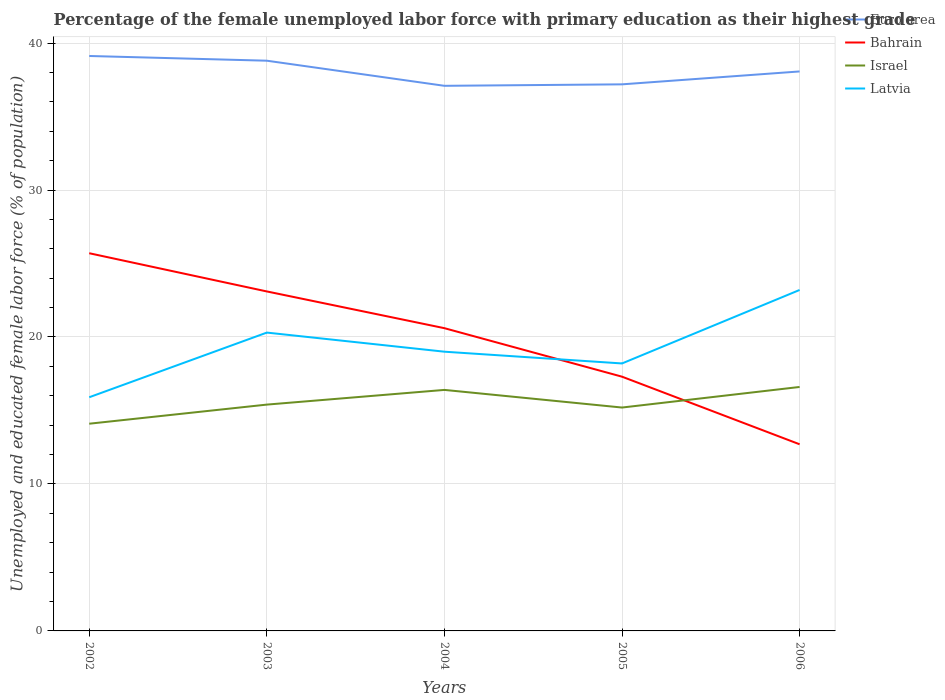Across all years, what is the maximum percentage of the unemployed female labor force with primary education in Israel?
Give a very brief answer. 14.1. In which year was the percentage of the unemployed female labor force with primary education in Euro area maximum?
Keep it short and to the point. 2004. What is the total percentage of the unemployed female labor force with primary education in Latvia in the graph?
Your response must be concise. -4.2. What is the difference between the highest and the second highest percentage of the unemployed female labor force with primary education in Latvia?
Your response must be concise. 7.3. What is the difference between the highest and the lowest percentage of the unemployed female labor force with primary education in Euro area?
Ensure brevity in your answer.  3. Is the percentage of the unemployed female labor force with primary education in Bahrain strictly greater than the percentage of the unemployed female labor force with primary education in Israel over the years?
Ensure brevity in your answer.  No. How many lines are there?
Provide a succinct answer. 4. Does the graph contain grids?
Provide a succinct answer. Yes. Where does the legend appear in the graph?
Your response must be concise. Top right. What is the title of the graph?
Keep it short and to the point. Percentage of the female unemployed labor force with primary education as their highest grade. Does "Bulgaria" appear as one of the legend labels in the graph?
Keep it short and to the point. No. What is the label or title of the Y-axis?
Offer a terse response. Unemployed and educated female labor force (% of population). What is the Unemployed and educated female labor force (% of population) of Euro area in 2002?
Your answer should be compact. 39.12. What is the Unemployed and educated female labor force (% of population) of Bahrain in 2002?
Offer a terse response. 25.7. What is the Unemployed and educated female labor force (% of population) of Israel in 2002?
Your answer should be compact. 14.1. What is the Unemployed and educated female labor force (% of population) of Latvia in 2002?
Your answer should be compact. 15.9. What is the Unemployed and educated female labor force (% of population) of Euro area in 2003?
Keep it short and to the point. 38.8. What is the Unemployed and educated female labor force (% of population) in Bahrain in 2003?
Your answer should be compact. 23.1. What is the Unemployed and educated female labor force (% of population) in Israel in 2003?
Ensure brevity in your answer.  15.4. What is the Unemployed and educated female labor force (% of population) in Latvia in 2003?
Give a very brief answer. 20.3. What is the Unemployed and educated female labor force (% of population) of Euro area in 2004?
Provide a short and direct response. 37.09. What is the Unemployed and educated female labor force (% of population) in Bahrain in 2004?
Provide a short and direct response. 20.6. What is the Unemployed and educated female labor force (% of population) of Israel in 2004?
Offer a terse response. 16.4. What is the Unemployed and educated female labor force (% of population) of Euro area in 2005?
Provide a short and direct response. 37.19. What is the Unemployed and educated female labor force (% of population) in Bahrain in 2005?
Offer a terse response. 17.3. What is the Unemployed and educated female labor force (% of population) in Israel in 2005?
Provide a succinct answer. 15.2. What is the Unemployed and educated female labor force (% of population) in Latvia in 2005?
Offer a terse response. 18.2. What is the Unemployed and educated female labor force (% of population) of Euro area in 2006?
Provide a succinct answer. 38.07. What is the Unemployed and educated female labor force (% of population) in Bahrain in 2006?
Offer a very short reply. 12.7. What is the Unemployed and educated female labor force (% of population) in Israel in 2006?
Your answer should be compact. 16.6. What is the Unemployed and educated female labor force (% of population) in Latvia in 2006?
Your response must be concise. 23.2. Across all years, what is the maximum Unemployed and educated female labor force (% of population) in Euro area?
Ensure brevity in your answer.  39.12. Across all years, what is the maximum Unemployed and educated female labor force (% of population) in Bahrain?
Your answer should be compact. 25.7. Across all years, what is the maximum Unemployed and educated female labor force (% of population) of Israel?
Offer a very short reply. 16.6. Across all years, what is the maximum Unemployed and educated female labor force (% of population) of Latvia?
Provide a succinct answer. 23.2. Across all years, what is the minimum Unemployed and educated female labor force (% of population) in Euro area?
Make the answer very short. 37.09. Across all years, what is the minimum Unemployed and educated female labor force (% of population) in Bahrain?
Your answer should be compact. 12.7. Across all years, what is the minimum Unemployed and educated female labor force (% of population) of Israel?
Provide a succinct answer. 14.1. Across all years, what is the minimum Unemployed and educated female labor force (% of population) of Latvia?
Make the answer very short. 15.9. What is the total Unemployed and educated female labor force (% of population) of Euro area in the graph?
Keep it short and to the point. 190.27. What is the total Unemployed and educated female labor force (% of population) in Bahrain in the graph?
Offer a very short reply. 99.4. What is the total Unemployed and educated female labor force (% of population) in Israel in the graph?
Give a very brief answer. 77.7. What is the total Unemployed and educated female labor force (% of population) in Latvia in the graph?
Your response must be concise. 96.6. What is the difference between the Unemployed and educated female labor force (% of population) in Euro area in 2002 and that in 2003?
Make the answer very short. 0.32. What is the difference between the Unemployed and educated female labor force (% of population) in Bahrain in 2002 and that in 2003?
Offer a very short reply. 2.6. What is the difference between the Unemployed and educated female labor force (% of population) in Israel in 2002 and that in 2003?
Offer a very short reply. -1.3. What is the difference between the Unemployed and educated female labor force (% of population) of Latvia in 2002 and that in 2003?
Offer a very short reply. -4.4. What is the difference between the Unemployed and educated female labor force (% of population) of Euro area in 2002 and that in 2004?
Your answer should be compact. 2.03. What is the difference between the Unemployed and educated female labor force (% of population) of Euro area in 2002 and that in 2005?
Provide a succinct answer. 1.93. What is the difference between the Unemployed and educated female labor force (% of population) in Israel in 2002 and that in 2005?
Provide a short and direct response. -1.1. What is the difference between the Unemployed and educated female labor force (% of population) in Latvia in 2002 and that in 2005?
Keep it short and to the point. -2.3. What is the difference between the Unemployed and educated female labor force (% of population) in Euro area in 2002 and that in 2006?
Your answer should be compact. 1.05. What is the difference between the Unemployed and educated female labor force (% of population) of Bahrain in 2002 and that in 2006?
Offer a terse response. 13. What is the difference between the Unemployed and educated female labor force (% of population) in Israel in 2002 and that in 2006?
Your answer should be compact. -2.5. What is the difference between the Unemployed and educated female labor force (% of population) in Euro area in 2003 and that in 2004?
Keep it short and to the point. 1.71. What is the difference between the Unemployed and educated female labor force (% of population) of Bahrain in 2003 and that in 2004?
Ensure brevity in your answer.  2.5. What is the difference between the Unemployed and educated female labor force (% of population) in Israel in 2003 and that in 2004?
Your response must be concise. -1. What is the difference between the Unemployed and educated female labor force (% of population) of Euro area in 2003 and that in 2005?
Provide a short and direct response. 1.61. What is the difference between the Unemployed and educated female labor force (% of population) of Euro area in 2003 and that in 2006?
Give a very brief answer. 0.73. What is the difference between the Unemployed and educated female labor force (% of population) in Euro area in 2004 and that in 2005?
Provide a succinct answer. -0.1. What is the difference between the Unemployed and educated female labor force (% of population) of Israel in 2004 and that in 2005?
Ensure brevity in your answer.  1.2. What is the difference between the Unemployed and educated female labor force (% of population) of Latvia in 2004 and that in 2005?
Offer a terse response. 0.8. What is the difference between the Unemployed and educated female labor force (% of population) in Euro area in 2004 and that in 2006?
Offer a terse response. -0.98. What is the difference between the Unemployed and educated female labor force (% of population) in Euro area in 2005 and that in 2006?
Your response must be concise. -0.88. What is the difference between the Unemployed and educated female labor force (% of population) of Bahrain in 2005 and that in 2006?
Ensure brevity in your answer.  4.6. What is the difference between the Unemployed and educated female labor force (% of population) in Euro area in 2002 and the Unemployed and educated female labor force (% of population) in Bahrain in 2003?
Make the answer very short. 16.02. What is the difference between the Unemployed and educated female labor force (% of population) of Euro area in 2002 and the Unemployed and educated female labor force (% of population) of Israel in 2003?
Keep it short and to the point. 23.72. What is the difference between the Unemployed and educated female labor force (% of population) in Euro area in 2002 and the Unemployed and educated female labor force (% of population) in Latvia in 2003?
Give a very brief answer. 18.82. What is the difference between the Unemployed and educated female labor force (% of population) in Bahrain in 2002 and the Unemployed and educated female labor force (% of population) in Latvia in 2003?
Make the answer very short. 5.4. What is the difference between the Unemployed and educated female labor force (% of population) of Euro area in 2002 and the Unemployed and educated female labor force (% of population) of Bahrain in 2004?
Ensure brevity in your answer.  18.52. What is the difference between the Unemployed and educated female labor force (% of population) of Euro area in 2002 and the Unemployed and educated female labor force (% of population) of Israel in 2004?
Keep it short and to the point. 22.72. What is the difference between the Unemployed and educated female labor force (% of population) in Euro area in 2002 and the Unemployed and educated female labor force (% of population) in Latvia in 2004?
Your answer should be compact. 20.12. What is the difference between the Unemployed and educated female labor force (% of population) of Bahrain in 2002 and the Unemployed and educated female labor force (% of population) of Israel in 2004?
Keep it short and to the point. 9.3. What is the difference between the Unemployed and educated female labor force (% of population) of Israel in 2002 and the Unemployed and educated female labor force (% of population) of Latvia in 2004?
Provide a succinct answer. -4.9. What is the difference between the Unemployed and educated female labor force (% of population) of Euro area in 2002 and the Unemployed and educated female labor force (% of population) of Bahrain in 2005?
Ensure brevity in your answer.  21.82. What is the difference between the Unemployed and educated female labor force (% of population) in Euro area in 2002 and the Unemployed and educated female labor force (% of population) in Israel in 2005?
Provide a short and direct response. 23.92. What is the difference between the Unemployed and educated female labor force (% of population) of Euro area in 2002 and the Unemployed and educated female labor force (% of population) of Latvia in 2005?
Provide a succinct answer. 20.92. What is the difference between the Unemployed and educated female labor force (% of population) of Bahrain in 2002 and the Unemployed and educated female labor force (% of population) of Latvia in 2005?
Offer a very short reply. 7.5. What is the difference between the Unemployed and educated female labor force (% of population) of Euro area in 2002 and the Unemployed and educated female labor force (% of population) of Bahrain in 2006?
Make the answer very short. 26.42. What is the difference between the Unemployed and educated female labor force (% of population) in Euro area in 2002 and the Unemployed and educated female labor force (% of population) in Israel in 2006?
Ensure brevity in your answer.  22.52. What is the difference between the Unemployed and educated female labor force (% of population) of Euro area in 2002 and the Unemployed and educated female labor force (% of population) of Latvia in 2006?
Provide a succinct answer. 15.92. What is the difference between the Unemployed and educated female labor force (% of population) in Bahrain in 2002 and the Unemployed and educated female labor force (% of population) in Israel in 2006?
Make the answer very short. 9.1. What is the difference between the Unemployed and educated female labor force (% of population) in Bahrain in 2002 and the Unemployed and educated female labor force (% of population) in Latvia in 2006?
Your response must be concise. 2.5. What is the difference between the Unemployed and educated female labor force (% of population) of Israel in 2002 and the Unemployed and educated female labor force (% of population) of Latvia in 2006?
Provide a short and direct response. -9.1. What is the difference between the Unemployed and educated female labor force (% of population) of Euro area in 2003 and the Unemployed and educated female labor force (% of population) of Bahrain in 2004?
Offer a very short reply. 18.2. What is the difference between the Unemployed and educated female labor force (% of population) in Euro area in 2003 and the Unemployed and educated female labor force (% of population) in Israel in 2004?
Make the answer very short. 22.4. What is the difference between the Unemployed and educated female labor force (% of population) of Euro area in 2003 and the Unemployed and educated female labor force (% of population) of Latvia in 2004?
Ensure brevity in your answer.  19.8. What is the difference between the Unemployed and educated female labor force (% of population) in Bahrain in 2003 and the Unemployed and educated female labor force (% of population) in Israel in 2004?
Your answer should be very brief. 6.7. What is the difference between the Unemployed and educated female labor force (% of population) in Bahrain in 2003 and the Unemployed and educated female labor force (% of population) in Latvia in 2004?
Ensure brevity in your answer.  4.1. What is the difference between the Unemployed and educated female labor force (% of population) of Israel in 2003 and the Unemployed and educated female labor force (% of population) of Latvia in 2004?
Provide a succinct answer. -3.6. What is the difference between the Unemployed and educated female labor force (% of population) in Euro area in 2003 and the Unemployed and educated female labor force (% of population) in Bahrain in 2005?
Ensure brevity in your answer.  21.5. What is the difference between the Unemployed and educated female labor force (% of population) in Euro area in 2003 and the Unemployed and educated female labor force (% of population) in Israel in 2005?
Give a very brief answer. 23.6. What is the difference between the Unemployed and educated female labor force (% of population) of Euro area in 2003 and the Unemployed and educated female labor force (% of population) of Latvia in 2005?
Provide a succinct answer. 20.6. What is the difference between the Unemployed and educated female labor force (% of population) in Bahrain in 2003 and the Unemployed and educated female labor force (% of population) in Israel in 2005?
Give a very brief answer. 7.9. What is the difference between the Unemployed and educated female labor force (% of population) of Euro area in 2003 and the Unemployed and educated female labor force (% of population) of Bahrain in 2006?
Make the answer very short. 26.1. What is the difference between the Unemployed and educated female labor force (% of population) in Euro area in 2003 and the Unemployed and educated female labor force (% of population) in Israel in 2006?
Your response must be concise. 22.2. What is the difference between the Unemployed and educated female labor force (% of population) in Euro area in 2003 and the Unemployed and educated female labor force (% of population) in Latvia in 2006?
Provide a succinct answer. 15.6. What is the difference between the Unemployed and educated female labor force (% of population) of Israel in 2003 and the Unemployed and educated female labor force (% of population) of Latvia in 2006?
Your response must be concise. -7.8. What is the difference between the Unemployed and educated female labor force (% of population) in Euro area in 2004 and the Unemployed and educated female labor force (% of population) in Bahrain in 2005?
Offer a terse response. 19.79. What is the difference between the Unemployed and educated female labor force (% of population) in Euro area in 2004 and the Unemployed and educated female labor force (% of population) in Israel in 2005?
Provide a succinct answer. 21.89. What is the difference between the Unemployed and educated female labor force (% of population) of Euro area in 2004 and the Unemployed and educated female labor force (% of population) of Latvia in 2005?
Your response must be concise. 18.89. What is the difference between the Unemployed and educated female labor force (% of population) of Bahrain in 2004 and the Unemployed and educated female labor force (% of population) of Israel in 2005?
Provide a short and direct response. 5.4. What is the difference between the Unemployed and educated female labor force (% of population) of Bahrain in 2004 and the Unemployed and educated female labor force (% of population) of Latvia in 2005?
Provide a succinct answer. 2.4. What is the difference between the Unemployed and educated female labor force (% of population) of Euro area in 2004 and the Unemployed and educated female labor force (% of population) of Bahrain in 2006?
Make the answer very short. 24.39. What is the difference between the Unemployed and educated female labor force (% of population) of Euro area in 2004 and the Unemployed and educated female labor force (% of population) of Israel in 2006?
Your answer should be very brief. 20.49. What is the difference between the Unemployed and educated female labor force (% of population) in Euro area in 2004 and the Unemployed and educated female labor force (% of population) in Latvia in 2006?
Ensure brevity in your answer.  13.89. What is the difference between the Unemployed and educated female labor force (% of population) of Bahrain in 2004 and the Unemployed and educated female labor force (% of population) of Latvia in 2006?
Your answer should be compact. -2.6. What is the difference between the Unemployed and educated female labor force (% of population) in Israel in 2004 and the Unemployed and educated female labor force (% of population) in Latvia in 2006?
Offer a terse response. -6.8. What is the difference between the Unemployed and educated female labor force (% of population) in Euro area in 2005 and the Unemployed and educated female labor force (% of population) in Bahrain in 2006?
Your answer should be very brief. 24.49. What is the difference between the Unemployed and educated female labor force (% of population) of Euro area in 2005 and the Unemployed and educated female labor force (% of population) of Israel in 2006?
Make the answer very short. 20.59. What is the difference between the Unemployed and educated female labor force (% of population) in Euro area in 2005 and the Unemployed and educated female labor force (% of population) in Latvia in 2006?
Give a very brief answer. 13.99. What is the average Unemployed and educated female labor force (% of population) of Euro area per year?
Your answer should be very brief. 38.05. What is the average Unemployed and educated female labor force (% of population) of Bahrain per year?
Give a very brief answer. 19.88. What is the average Unemployed and educated female labor force (% of population) of Israel per year?
Give a very brief answer. 15.54. What is the average Unemployed and educated female labor force (% of population) in Latvia per year?
Keep it short and to the point. 19.32. In the year 2002, what is the difference between the Unemployed and educated female labor force (% of population) in Euro area and Unemployed and educated female labor force (% of population) in Bahrain?
Offer a very short reply. 13.42. In the year 2002, what is the difference between the Unemployed and educated female labor force (% of population) of Euro area and Unemployed and educated female labor force (% of population) of Israel?
Your answer should be compact. 25.02. In the year 2002, what is the difference between the Unemployed and educated female labor force (% of population) in Euro area and Unemployed and educated female labor force (% of population) in Latvia?
Ensure brevity in your answer.  23.22. In the year 2002, what is the difference between the Unemployed and educated female labor force (% of population) of Bahrain and Unemployed and educated female labor force (% of population) of Latvia?
Give a very brief answer. 9.8. In the year 2003, what is the difference between the Unemployed and educated female labor force (% of population) in Euro area and Unemployed and educated female labor force (% of population) in Bahrain?
Keep it short and to the point. 15.7. In the year 2003, what is the difference between the Unemployed and educated female labor force (% of population) of Euro area and Unemployed and educated female labor force (% of population) of Israel?
Keep it short and to the point. 23.4. In the year 2003, what is the difference between the Unemployed and educated female labor force (% of population) of Euro area and Unemployed and educated female labor force (% of population) of Latvia?
Provide a succinct answer. 18.5. In the year 2003, what is the difference between the Unemployed and educated female labor force (% of population) of Bahrain and Unemployed and educated female labor force (% of population) of Israel?
Ensure brevity in your answer.  7.7. In the year 2003, what is the difference between the Unemployed and educated female labor force (% of population) of Bahrain and Unemployed and educated female labor force (% of population) of Latvia?
Provide a succinct answer. 2.8. In the year 2004, what is the difference between the Unemployed and educated female labor force (% of population) of Euro area and Unemployed and educated female labor force (% of population) of Bahrain?
Your answer should be very brief. 16.49. In the year 2004, what is the difference between the Unemployed and educated female labor force (% of population) in Euro area and Unemployed and educated female labor force (% of population) in Israel?
Keep it short and to the point. 20.69. In the year 2004, what is the difference between the Unemployed and educated female labor force (% of population) of Euro area and Unemployed and educated female labor force (% of population) of Latvia?
Your answer should be very brief. 18.09. In the year 2004, what is the difference between the Unemployed and educated female labor force (% of population) in Bahrain and Unemployed and educated female labor force (% of population) in Latvia?
Provide a short and direct response. 1.6. In the year 2005, what is the difference between the Unemployed and educated female labor force (% of population) in Euro area and Unemployed and educated female labor force (% of population) in Bahrain?
Your answer should be very brief. 19.89. In the year 2005, what is the difference between the Unemployed and educated female labor force (% of population) in Euro area and Unemployed and educated female labor force (% of population) in Israel?
Provide a short and direct response. 21.99. In the year 2005, what is the difference between the Unemployed and educated female labor force (% of population) of Euro area and Unemployed and educated female labor force (% of population) of Latvia?
Your answer should be very brief. 18.99. In the year 2005, what is the difference between the Unemployed and educated female labor force (% of population) in Bahrain and Unemployed and educated female labor force (% of population) in Latvia?
Make the answer very short. -0.9. In the year 2006, what is the difference between the Unemployed and educated female labor force (% of population) in Euro area and Unemployed and educated female labor force (% of population) in Bahrain?
Your answer should be compact. 25.37. In the year 2006, what is the difference between the Unemployed and educated female labor force (% of population) of Euro area and Unemployed and educated female labor force (% of population) of Israel?
Your answer should be very brief. 21.47. In the year 2006, what is the difference between the Unemployed and educated female labor force (% of population) in Euro area and Unemployed and educated female labor force (% of population) in Latvia?
Give a very brief answer. 14.87. In the year 2006, what is the difference between the Unemployed and educated female labor force (% of population) of Bahrain and Unemployed and educated female labor force (% of population) of Latvia?
Offer a terse response. -10.5. In the year 2006, what is the difference between the Unemployed and educated female labor force (% of population) in Israel and Unemployed and educated female labor force (% of population) in Latvia?
Give a very brief answer. -6.6. What is the ratio of the Unemployed and educated female labor force (% of population) in Euro area in 2002 to that in 2003?
Make the answer very short. 1.01. What is the ratio of the Unemployed and educated female labor force (% of population) of Bahrain in 2002 to that in 2003?
Give a very brief answer. 1.11. What is the ratio of the Unemployed and educated female labor force (% of population) in Israel in 2002 to that in 2003?
Your answer should be very brief. 0.92. What is the ratio of the Unemployed and educated female labor force (% of population) of Latvia in 2002 to that in 2003?
Provide a short and direct response. 0.78. What is the ratio of the Unemployed and educated female labor force (% of population) in Euro area in 2002 to that in 2004?
Keep it short and to the point. 1.05. What is the ratio of the Unemployed and educated female labor force (% of population) of Bahrain in 2002 to that in 2004?
Provide a short and direct response. 1.25. What is the ratio of the Unemployed and educated female labor force (% of population) in Israel in 2002 to that in 2004?
Keep it short and to the point. 0.86. What is the ratio of the Unemployed and educated female labor force (% of population) of Latvia in 2002 to that in 2004?
Offer a very short reply. 0.84. What is the ratio of the Unemployed and educated female labor force (% of population) in Euro area in 2002 to that in 2005?
Keep it short and to the point. 1.05. What is the ratio of the Unemployed and educated female labor force (% of population) in Bahrain in 2002 to that in 2005?
Offer a very short reply. 1.49. What is the ratio of the Unemployed and educated female labor force (% of population) of Israel in 2002 to that in 2005?
Your answer should be compact. 0.93. What is the ratio of the Unemployed and educated female labor force (% of population) of Latvia in 2002 to that in 2005?
Keep it short and to the point. 0.87. What is the ratio of the Unemployed and educated female labor force (% of population) in Euro area in 2002 to that in 2006?
Keep it short and to the point. 1.03. What is the ratio of the Unemployed and educated female labor force (% of population) in Bahrain in 2002 to that in 2006?
Provide a succinct answer. 2.02. What is the ratio of the Unemployed and educated female labor force (% of population) in Israel in 2002 to that in 2006?
Provide a short and direct response. 0.85. What is the ratio of the Unemployed and educated female labor force (% of population) of Latvia in 2002 to that in 2006?
Your answer should be compact. 0.69. What is the ratio of the Unemployed and educated female labor force (% of population) in Euro area in 2003 to that in 2004?
Provide a short and direct response. 1.05. What is the ratio of the Unemployed and educated female labor force (% of population) of Bahrain in 2003 to that in 2004?
Ensure brevity in your answer.  1.12. What is the ratio of the Unemployed and educated female labor force (% of population) in Israel in 2003 to that in 2004?
Your answer should be compact. 0.94. What is the ratio of the Unemployed and educated female labor force (% of population) of Latvia in 2003 to that in 2004?
Provide a short and direct response. 1.07. What is the ratio of the Unemployed and educated female labor force (% of population) in Euro area in 2003 to that in 2005?
Offer a terse response. 1.04. What is the ratio of the Unemployed and educated female labor force (% of population) in Bahrain in 2003 to that in 2005?
Offer a terse response. 1.34. What is the ratio of the Unemployed and educated female labor force (% of population) in Israel in 2003 to that in 2005?
Your response must be concise. 1.01. What is the ratio of the Unemployed and educated female labor force (% of population) in Latvia in 2003 to that in 2005?
Provide a short and direct response. 1.12. What is the ratio of the Unemployed and educated female labor force (% of population) in Euro area in 2003 to that in 2006?
Your answer should be very brief. 1.02. What is the ratio of the Unemployed and educated female labor force (% of population) of Bahrain in 2003 to that in 2006?
Give a very brief answer. 1.82. What is the ratio of the Unemployed and educated female labor force (% of population) in Israel in 2003 to that in 2006?
Your answer should be compact. 0.93. What is the ratio of the Unemployed and educated female labor force (% of population) of Bahrain in 2004 to that in 2005?
Ensure brevity in your answer.  1.19. What is the ratio of the Unemployed and educated female labor force (% of population) of Israel in 2004 to that in 2005?
Provide a short and direct response. 1.08. What is the ratio of the Unemployed and educated female labor force (% of population) of Latvia in 2004 to that in 2005?
Your response must be concise. 1.04. What is the ratio of the Unemployed and educated female labor force (% of population) in Euro area in 2004 to that in 2006?
Provide a succinct answer. 0.97. What is the ratio of the Unemployed and educated female labor force (% of population) of Bahrain in 2004 to that in 2006?
Provide a succinct answer. 1.62. What is the ratio of the Unemployed and educated female labor force (% of population) in Latvia in 2004 to that in 2006?
Make the answer very short. 0.82. What is the ratio of the Unemployed and educated female labor force (% of population) in Euro area in 2005 to that in 2006?
Give a very brief answer. 0.98. What is the ratio of the Unemployed and educated female labor force (% of population) in Bahrain in 2005 to that in 2006?
Keep it short and to the point. 1.36. What is the ratio of the Unemployed and educated female labor force (% of population) of Israel in 2005 to that in 2006?
Your response must be concise. 0.92. What is the ratio of the Unemployed and educated female labor force (% of population) in Latvia in 2005 to that in 2006?
Ensure brevity in your answer.  0.78. What is the difference between the highest and the second highest Unemployed and educated female labor force (% of population) of Euro area?
Ensure brevity in your answer.  0.32. What is the difference between the highest and the second highest Unemployed and educated female labor force (% of population) of Bahrain?
Your response must be concise. 2.6. What is the difference between the highest and the second highest Unemployed and educated female labor force (% of population) in Latvia?
Provide a short and direct response. 2.9. What is the difference between the highest and the lowest Unemployed and educated female labor force (% of population) of Euro area?
Give a very brief answer. 2.03. What is the difference between the highest and the lowest Unemployed and educated female labor force (% of population) of Latvia?
Keep it short and to the point. 7.3. 